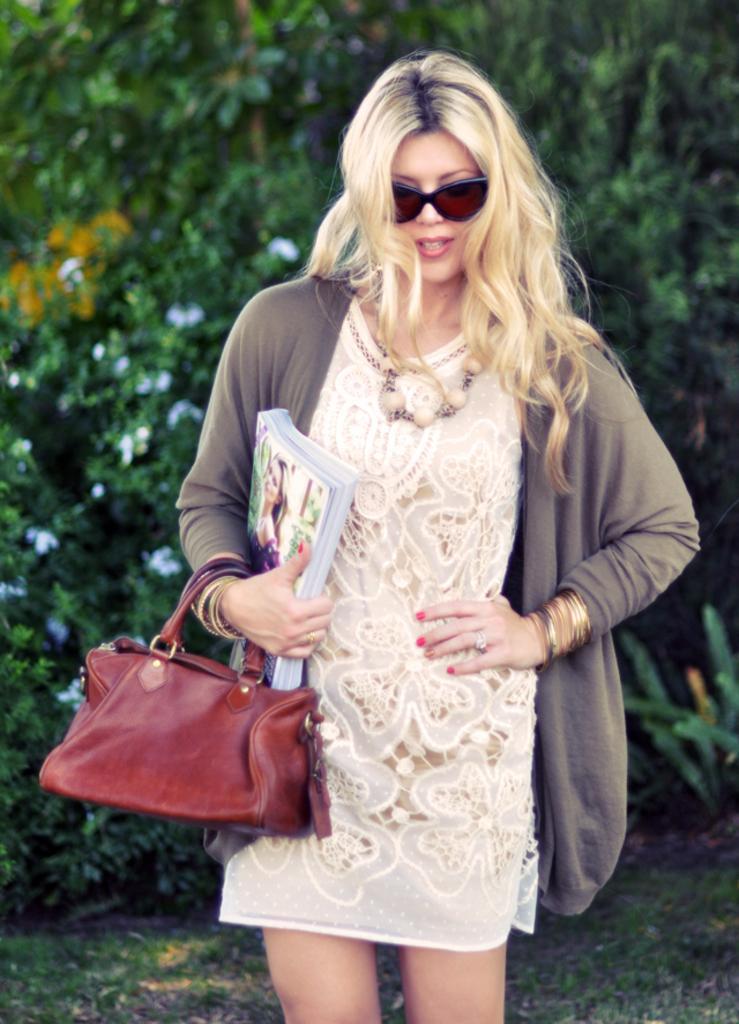Please provide a concise description of this image. In the image we can see there is a women who is holding books in her hand and she is carrying a purse. Behind her there are lot of trees and the ground covered with grass. 